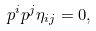Convert formula to latex. <formula><loc_0><loc_0><loc_500><loc_500>p ^ { i } p ^ { j } \eta _ { i j } = 0 ,</formula> 